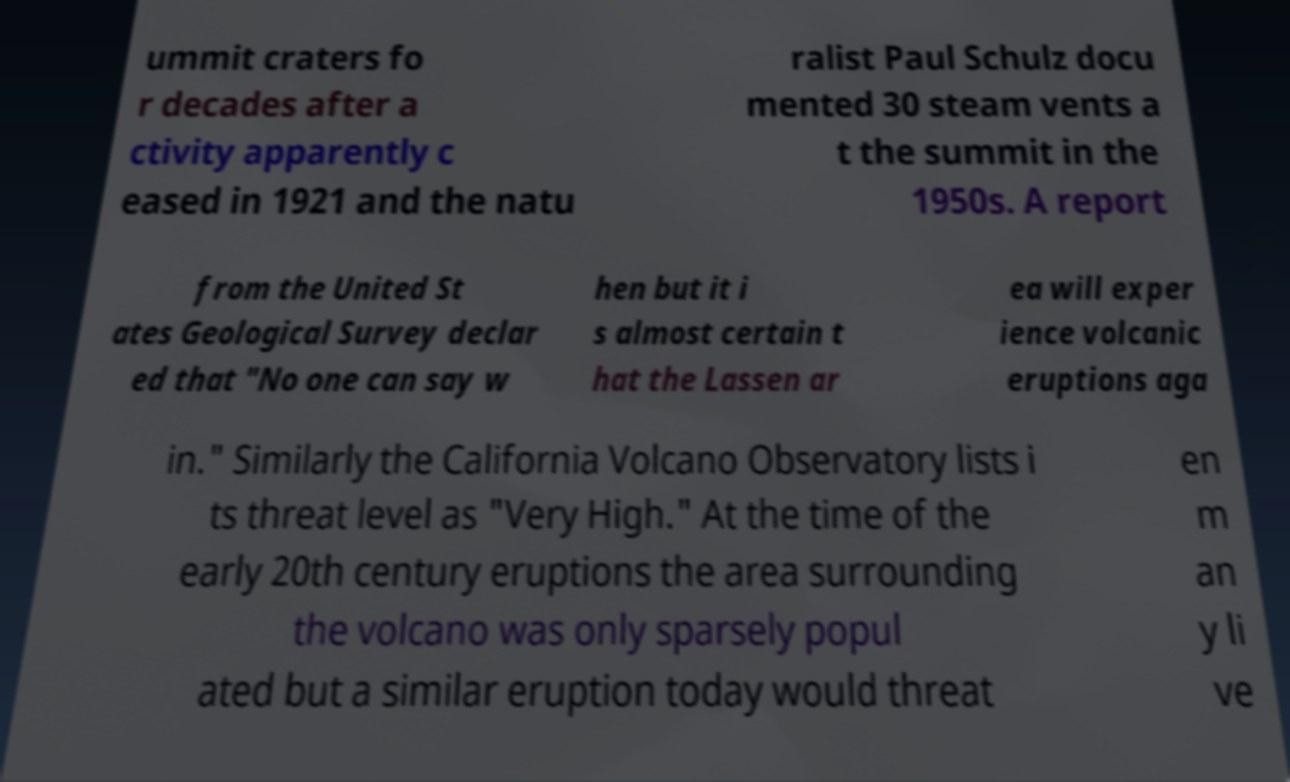Can you accurately transcribe the text from the provided image for me? ummit craters fo r decades after a ctivity apparently c eased in 1921 and the natu ralist Paul Schulz docu mented 30 steam vents a t the summit in the 1950s. A report from the United St ates Geological Survey declar ed that "No one can say w hen but it i s almost certain t hat the Lassen ar ea will exper ience volcanic eruptions aga in." Similarly the California Volcano Observatory lists i ts threat level as "Very High." At the time of the early 20th century eruptions the area surrounding the volcano was only sparsely popul ated but a similar eruption today would threat en m an y li ve 